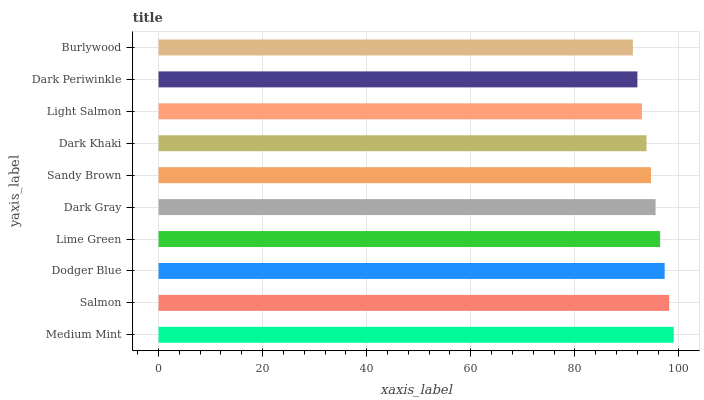Is Burlywood the minimum?
Answer yes or no. Yes. Is Medium Mint the maximum?
Answer yes or no. Yes. Is Salmon the minimum?
Answer yes or no. No. Is Salmon the maximum?
Answer yes or no. No. Is Medium Mint greater than Salmon?
Answer yes or no. Yes. Is Salmon less than Medium Mint?
Answer yes or no. Yes. Is Salmon greater than Medium Mint?
Answer yes or no. No. Is Medium Mint less than Salmon?
Answer yes or no. No. Is Dark Gray the high median?
Answer yes or no. Yes. Is Sandy Brown the low median?
Answer yes or no. Yes. Is Sandy Brown the high median?
Answer yes or no. No. Is Burlywood the low median?
Answer yes or no. No. 